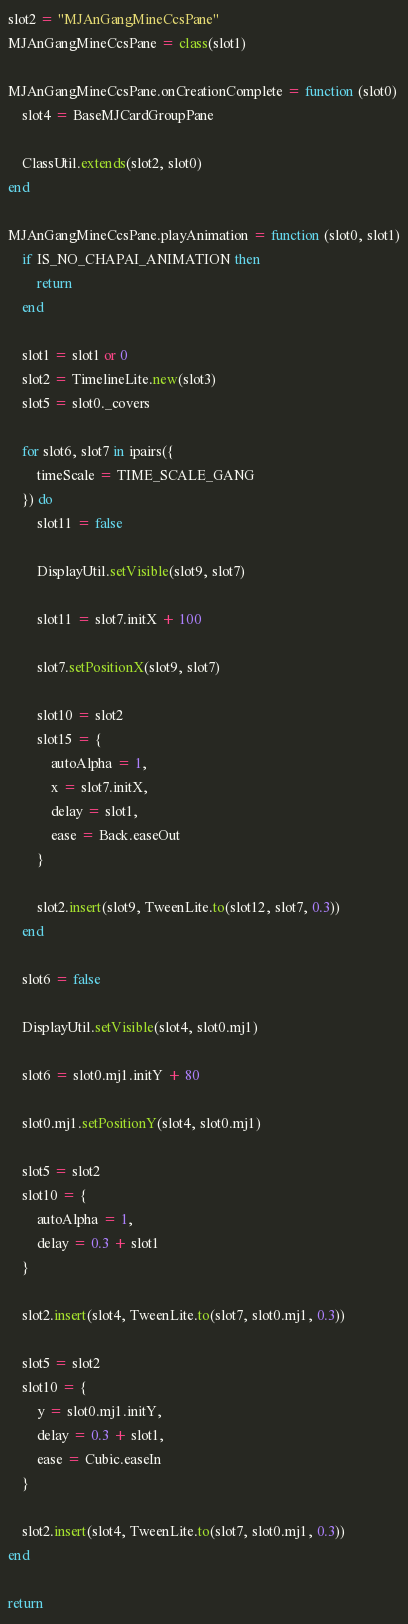Convert code to text. <code><loc_0><loc_0><loc_500><loc_500><_Lua_>slot2 = "MJAnGangMineCcsPane"
MJAnGangMineCcsPane = class(slot1)

MJAnGangMineCcsPane.onCreationComplete = function (slot0)
	slot4 = BaseMJCardGroupPane

	ClassUtil.extends(slot2, slot0)
end

MJAnGangMineCcsPane.playAnimation = function (slot0, slot1)
	if IS_NO_CHAPAI_ANIMATION then
		return
	end

	slot1 = slot1 or 0
	slot2 = TimelineLite.new(slot3)
	slot5 = slot0._covers

	for slot6, slot7 in ipairs({
		timeScale = TIME_SCALE_GANG
	}) do
		slot11 = false

		DisplayUtil.setVisible(slot9, slot7)

		slot11 = slot7.initX + 100

		slot7.setPositionX(slot9, slot7)

		slot10 = slot2
		slot15 = {
			autoAlpha = 1,
			x = slot7.initX,
			delay = slot1,
			ease = Back.easeOut
		}

		slot2.insert(slot9, TweenLite.to(slot12, slot7, 0.3))
	end

	slot6 = false

	DisplayUtil.setVisible(slot4, slot0.mj1)

	slot6 = slot0.mj1.initY + 80

	slot0.mj1.setPositionY(slot4, slot0.mj1)

	slot5 = slot2
	slot10 = {
		autoAlpha = 1,
		delay = 0.3 + slot1
	}

	slot2.insert(slot4, TweenLite.to(slot7, slot0.mj1, 0.3))

	slot5 = slot2
	slot10 = {
		y = slot0.mj1.initY,
		delay = 0.3 + slot1,
		ease = Cubic.easeIn
	}

	slot2.insert(slot4, TweenLite.to(slot7, slot0.mj1, 0.3))
end

return
</code> 